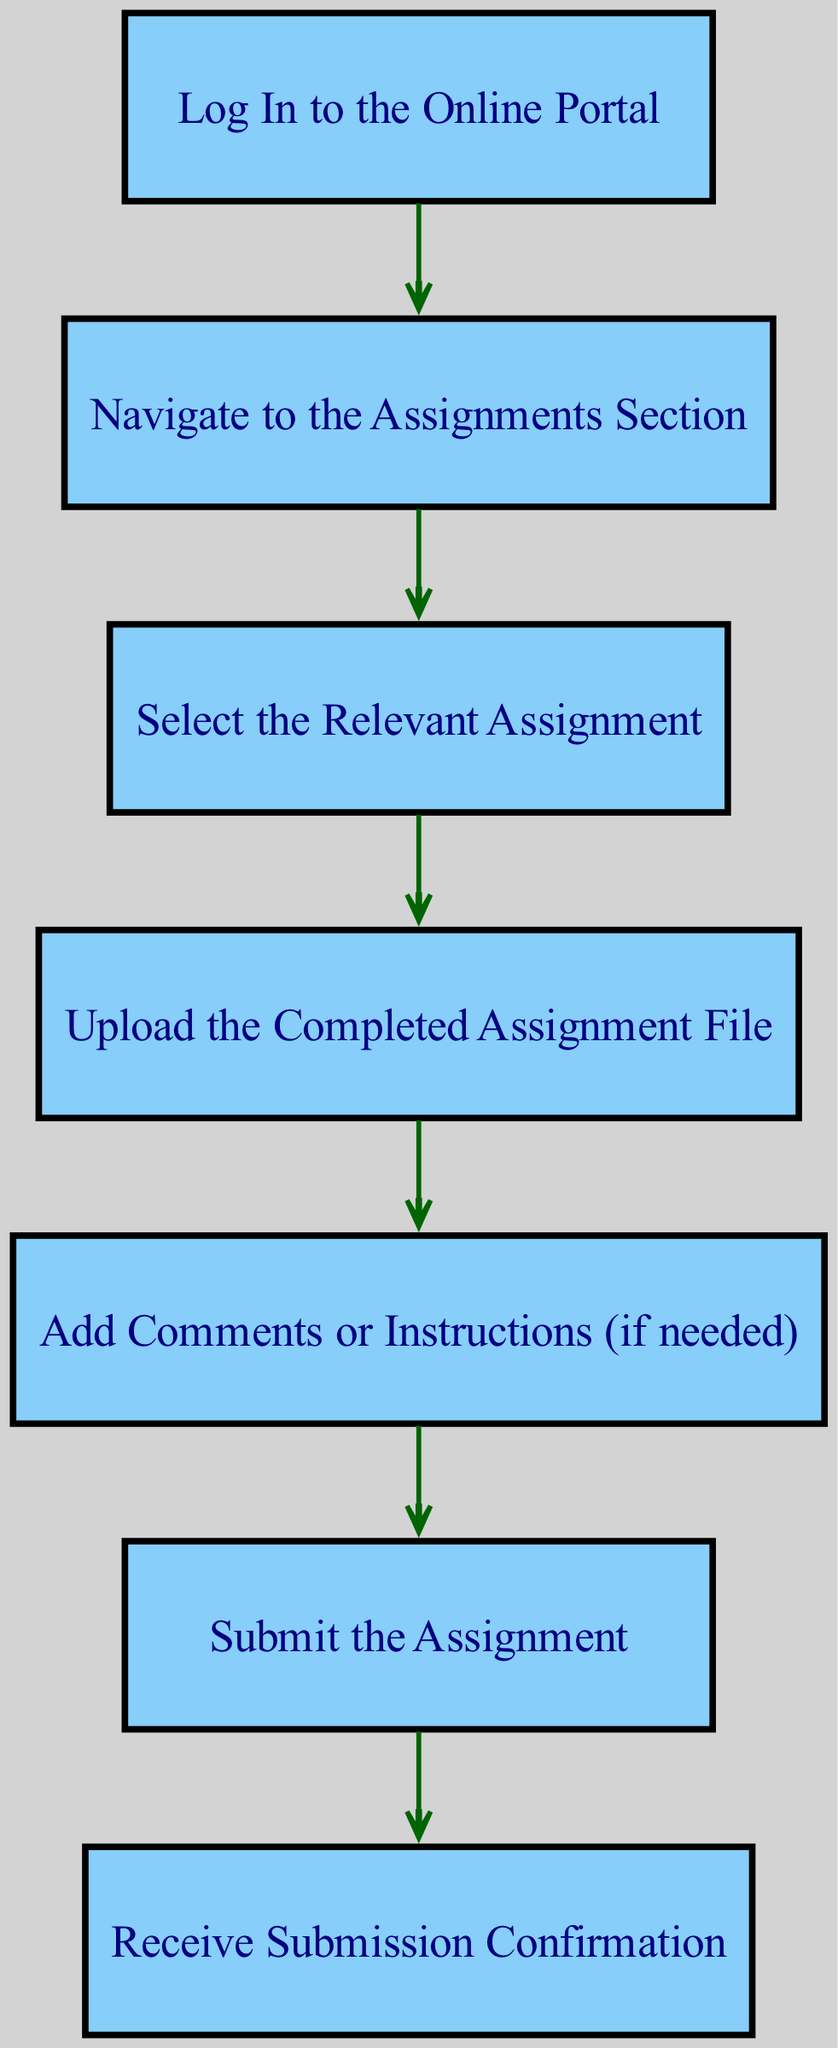What is the first step in the assignment submission workflow? The first step is "Log In to the Online Portal," as indicated by the starting node in the diagram.
Answer: Log In to the Online Portal How many nodes are present in the diagram? Counting all distinct nodes listed, there are 7 nodes in total representing each step of the workflow.
Answer: 7 What is the immediate next step after "Upload the Completed Assignment File"? The immediate next step is "Add Comments or Instructions (if needed)," which is connected directly to the "Upload File" node.
Answer: Add Comments or Instructions (if needed) What nodes are connected directly to the "Submit" node? The only node connected directly to the "Submit" node is "Add Comments or Instructions (if needed)," indicating it must be completed just before submitting.
Answer: Add Comments or Instructions (if needed) Which step follows "Select the Relevant Assignment"? The step that follows "Select the Relevant Assignment" is "Upload the Completed Assignment File," as per the directed path shown in the diagram.
Answer: Upload the Completed Assignment File How many edges are in the diagram? Counting each connection that flows from one node to another, there are a total of 6 edges in the diagram.
Answer: 6 What is the outcome after "Submit the Assignment"? The outcome after submitting is "Receive Submission Confirmation," as shown by the directed edge leading from "Submit" to "Confirmation."
Answer: Receive Submission Confirmation What is the relationship between "Log In" and "Navigate to the Assignments Section"? "Log In" is the prerequisite step that must be completed before the "Navigate to the Assignments Section," indicated by the directed edge flowing from "Log In" to "Navigate."
Answer: Log In → Navigate to the Assignments Section What is the last step in the workflow? The last step in the workflow is "Receive Submission Confirmation," which shows it is the endpoint of the submission process.
Answer: Receive Submission Confirmation 